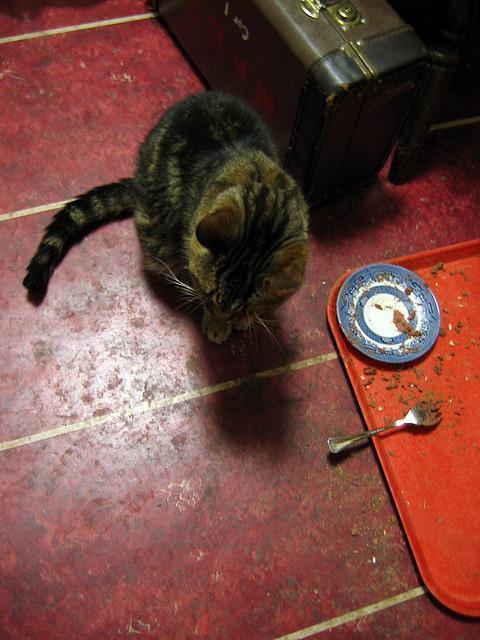How many people are wearing hats?
Give a very brief answer. 0. 